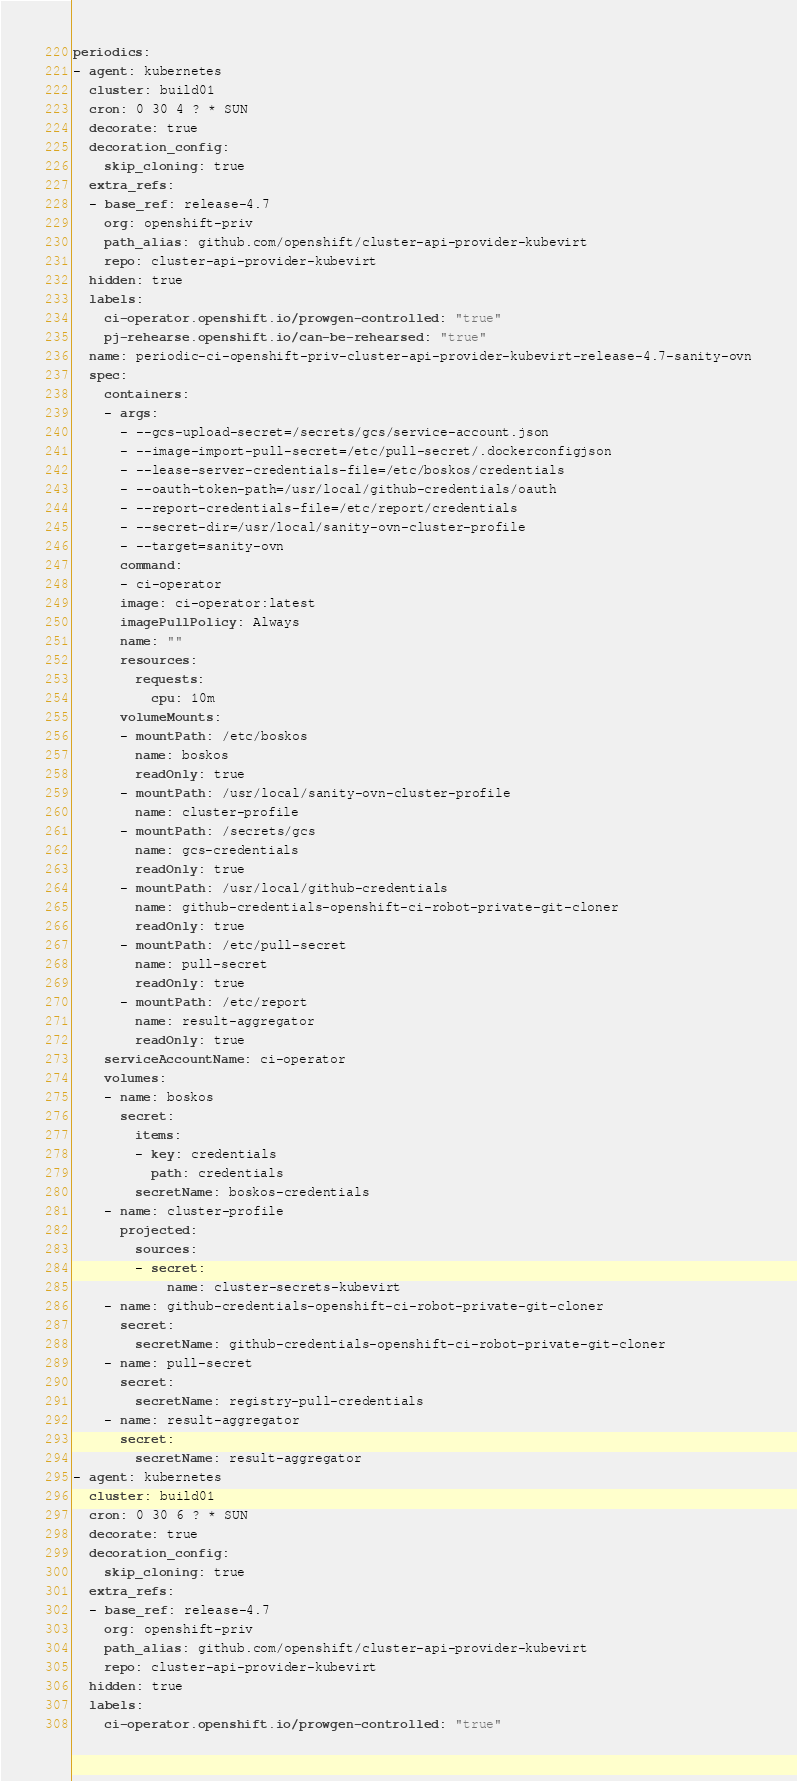<code> <loc_0><loc_0><loc_500><loc_500><_YAML_>periodics:
- agent: kubernetes
  cluster: build01
  cron: 0 30 4 ? * SUN
  decorate: true
  decoration_config:
    skip_cloning: true
  extra_refs:
  - base_ref: release-4.7
    org: openshift-priv
    path_alias: github.com/openshift/cluster-api-provider-kubevirt
    repo: cluster-api-provider-kubevirt
  hidden: true
  labels:
    ci-operator.openshift.io/prowgen-controlled: "true"
    pj-rehearse.openshift.io/can-be-rehearsed: "true"
  name: periodic-ci-openshift-priv-cluster-api-provider-kubevirt-release-4.7-sanity-ovn
  spec:
    containers:
    - args:
      - --gcs-upload-secret=/secrets/gcs/service-account.json
      - --image-import-pull-secret=/etc/pull-secret/.dockerconfigjson
      - --lease-server-credentials-file=/etc/boskos/credentials
      - --oauth-token-path=/usr/local/github-credentials/oauth
      - --report-credentials-file=/etc/report/credentials
      - --secret-dir=/usr/local/sanity-ovn-cluster-profile
      - --target=sanity-ovn
      command:
      - ci-operator
      image: ci-operator:latest
      imagePullPolicy: Always
      name: ""
      resources:
        requests:
          cpu: 10m
      volumeMounts:
      - mountPath: /etc/boskos
        name: boskos
        readOnly: true
      - mountPath: /usr/local/sanity-ovn-cluster-profile
        name: cluster-profile
      - mountPath: /secrets/gcs
        name: gcs-credentials
        readOnly: true
      - mountPath: /usr/local/github-credentials
        name: github-credentials-openshift-ci-robot-private-git-cloner
        readOnly: true
      - mountPath: /etc/pull-secret
        name: pull-secret
        readOnly: true
      - mountPath: /etc/report
        name: result-aggregator
        readOnly: true
    serviceAccountName: ci-operator
    volumes:
    - name: boskos
      secret:
        items:
        - key: credentials
          path: credentials
        secretName: boskos-credentials
    - name: cluster-profile
      projected:
        sources:
        - secret:
            name: cluster-secrets-kubevirt
    - name: github-credentials-openshift-ci-robot-private-git-cloner
      secret:
        secretName: github-credentials-openshift-ci-robot-private-git-cloner
    - name: pull-secret
      secret:
        secretName: registry-pull-credentials
    - name: result-aggregator
      secret:
        secretName: result-aggregator
- agent: kubernetes
  cluster: build01
  cron: 0 30 6 ? * SUN
  decorate: true
  decoration_config:
    skip_cloning: true
  extra_refs:
  - base_ref: release-4.7
    org: openshift-priv
    path_alias: github.com/openshift/cluster-api-provider-kubevirt
    repo: cluster-api-provider-kubevirt
  hidden: true
  labels:
    ci-operator.openshift.io/prowgen-controlled: "true"</code> 